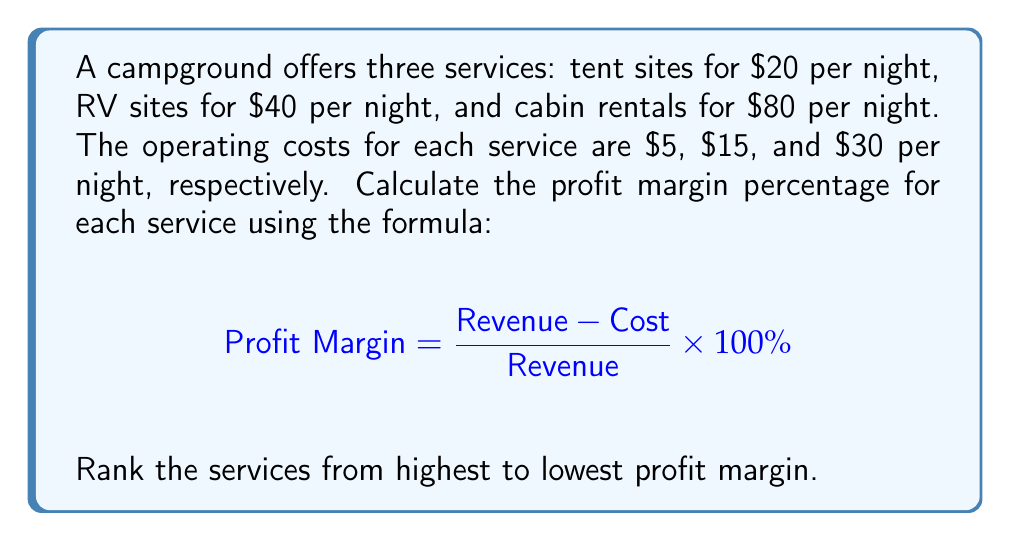Can you answer this question? Let's calculate the profit margin for each service:

1. Tent sites:
   Revenue = $20
   Cost = $5
   $$ \text{Profit Margin} = \frac{20 - 5}{20} \times 100\% = \frac{15}{20} \times 100\% = 75\% $$

2. RV sites:
   Revenue = $40
   Cost = $15
   $$ \text{Profit Margin} = \frac{40 - 15}{40} \times 100\% = \frac{25}{40} \times 100\% = 62.5\% $$

3. Cabin rentals:
   Revenue = $80
   Cost = $30
   $$ \text{Profit Margin} = \frac{80 - 30}{80} \times 100\% = \frac{50}{80} \times 100\% = 62.5\% $$

Ranking from highest to lowest profit margin:
1. Tent sites: 75%
2. RV sites: 62.5%
3. Cabin rentals: 62.5%

Note that RV sites and cabin rentals have the same profit margin.
Answer: Tent sites: 75%, RV sites: 62.5%, Cabin rentals: 62.5%. Ranked: Tent sites > RV sites = Cabin rentals. 